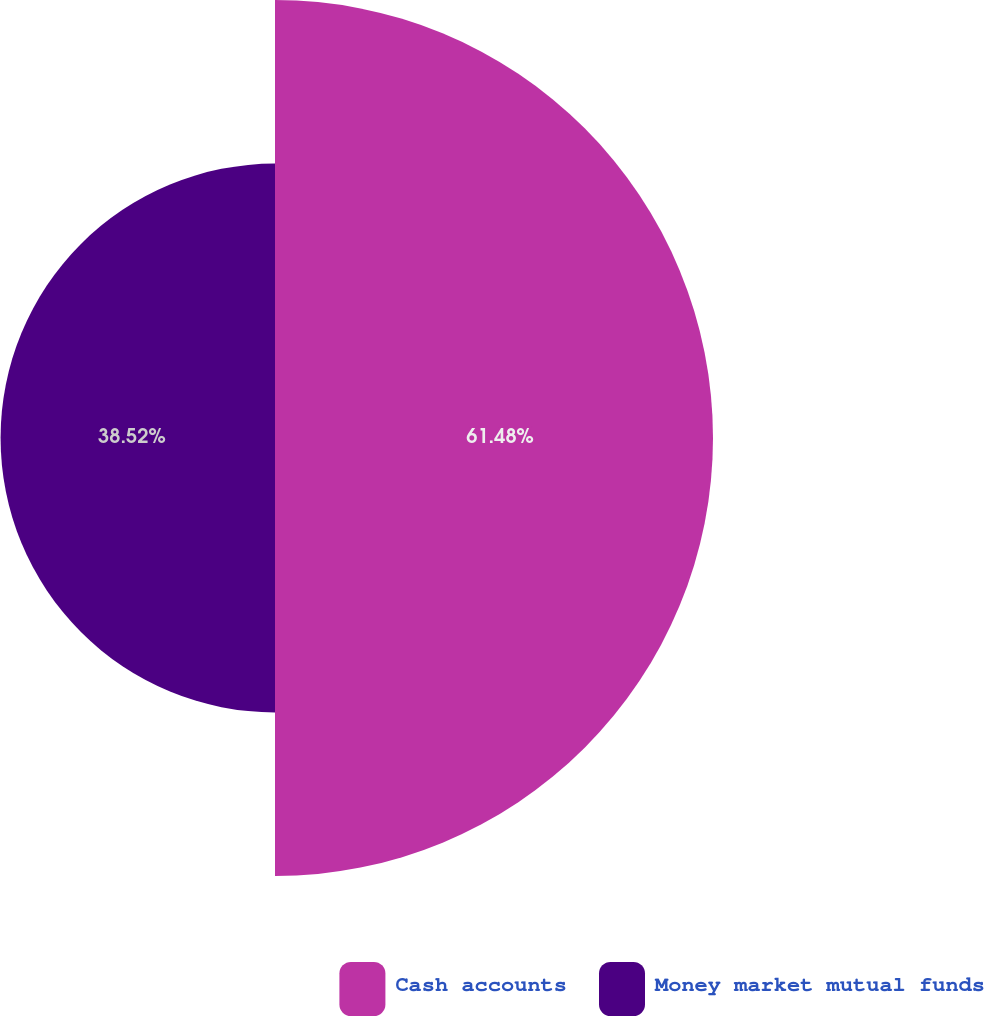Convert chart to OTSL. <chart><loc_0><loc_0><loc_500><loc_500><pie_chart><fcel>Cash accounts<fcel>Money market mutual funds<nl><fcel>61.48%<fcel>38.52%<nl></chart> 